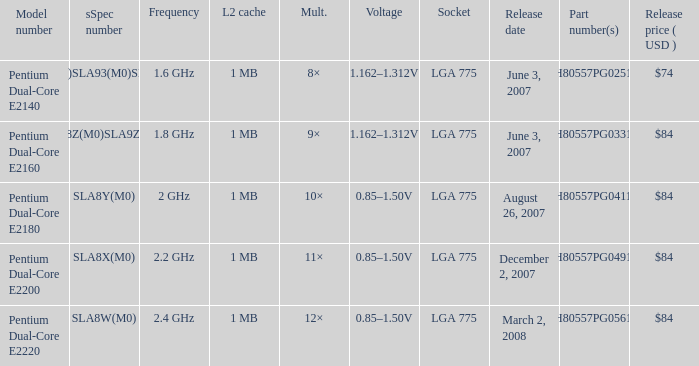Which component number(s) possess a HH80557PG0561M. 